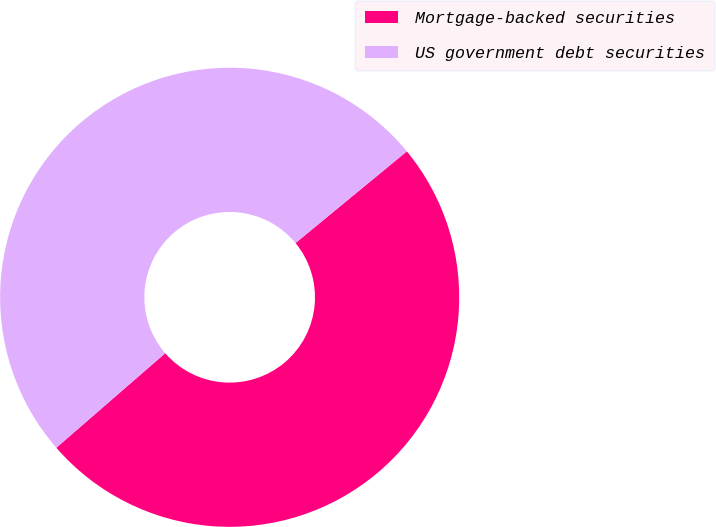<chart> <loc_0><loc_0><loc_500><loc_500><pie_chart><fcel>Mortgage-backed securities<fcel>US government debt securities<nl><fcel>49.59%<fcel>50.41%<nl></chart> 